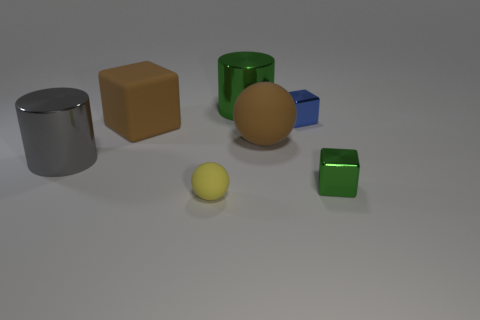There is a matte sphere behind the small green metal thing; is its color the same as the large block?
Your answer should be compact. Yes. How many other things are the same shape as the small blue object?
Give a very brief answer. 2. What number of other things are there of the same material as the large gray cylinder
Your response must be concise. 3. There is a brown thing that is to the right of the large cylinder on the right side of the matte ball that is to the left of the large green shiny thing; what is its material?
Provide a short and direct response. Rubber. Do the small yellow sphere and the big brown sphere have the same material?
Keep it short and to the point. Yes. What number of cubes are either large cyan things or blue shiny objects?
Provide a succinct answer. 1. There is a shiny cylinder that is right of the small rubber thing; what is its color?
Offer a very short reply. Green. What number of shiny objects are either yellow balls or small blocks?
Offer a terse response. 2. The small object in front of the metal thing that is in front of the gray shiny object is made of what material?
Your answer should be compact. Rubber. What material is the big cube that is the same color as the big sphere?
Make the answer very short. Rubber. 